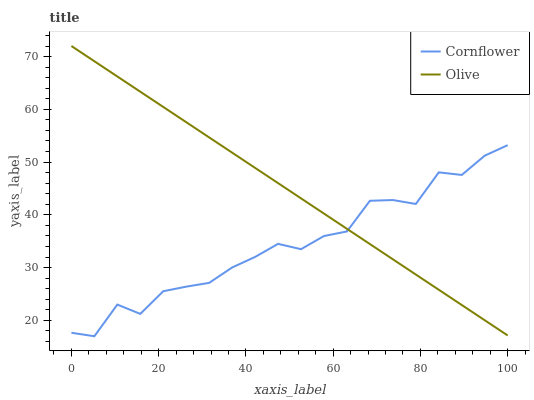Does Cornflower have the minimum area under the curve?
Answer yes or no. Yes. Does Olive have the maximum area under the curve?
Answer yes or no. Yes. Does Cornflower have the maximum area under the curve?
Answer yes or no. No. Is Olive the smoothest?
Answer yes or no. Yes. Is Cornflower the roughest?
Answer yes or no. Yes. Is Cornflower the smoothest?
Answer yes or no. No. Does Cornflower have the lowest value?
Answer yes or no. Yes. Does Olive have the highest value?
Answer yes or no. Yes. Does Cornflower have the highest value?
Answer yes or no. No. Does Cornflower intersect Olive?
Answer yes or no. Yes. Is Cornflower less than Olive?
Answer yes or no. No. Is Cornflower greater than Olive?
Answer yes or no. No. 